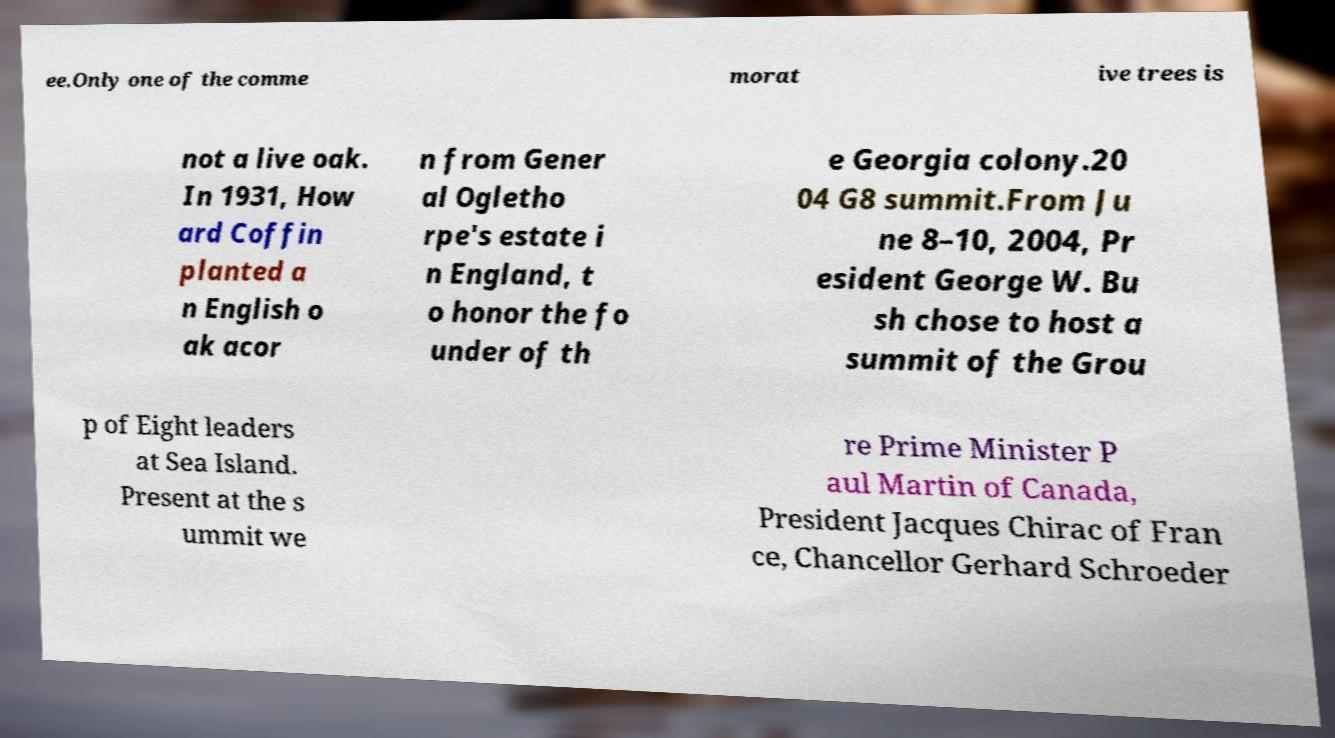Could you extract and type out the text from this image? ee.Only one of the comme morat ive trees is not a live oak. In 1931, How ard Coffin planted a n English o ak acor n from Gener al Ogletho rpe's estate i n England, t o honor the fo under of th e Georgia colony.20 04 G8 summit.From Ju ne 8–10, 2004, Pr esident George W. Bu sh chose to host a summit of the Grou p of Eight leaders at Sea Island. Present at the s ummit we re Prime Minister P aul Martin of Canada, President Jacques Chirac of Fran ce, Chancellor Gerhard Schroeder 